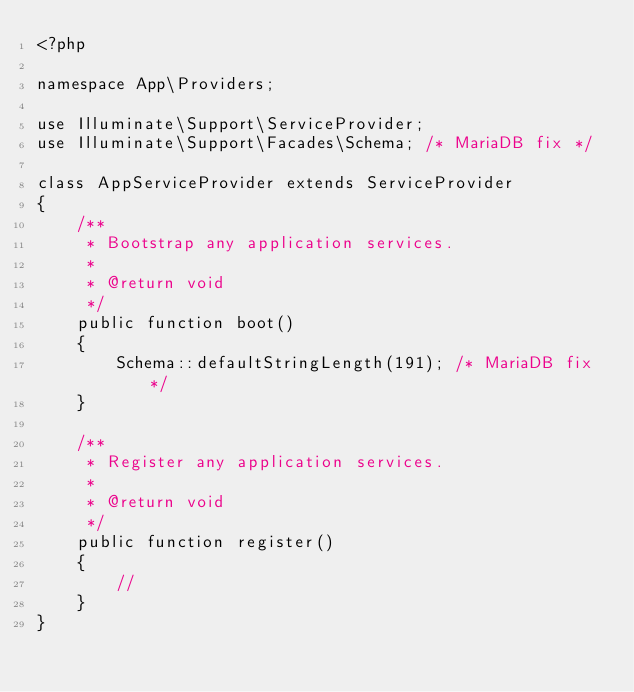<code> <loc_0><loc_0><loc_500><loc_500><_PHP_><?php

namespace App\Providers;

use Illuminate\Support\ServiceProvider;
use Illuminate\Support\Facades\Schema; /* MariaDB fix */

class AppServiceProvider extends ServiceProvider
{
    /** 
     * Bootstrap any application services.
     *
     * @return void
     */
    public function boot()
    {   
        Schema::defaultStringLength(191); /* MariaDB fix */
    }

    /** 
     * Register any application services.
     *
     * @return void
     */
    public function register()
    {   
        //  
    }   
}</code> 